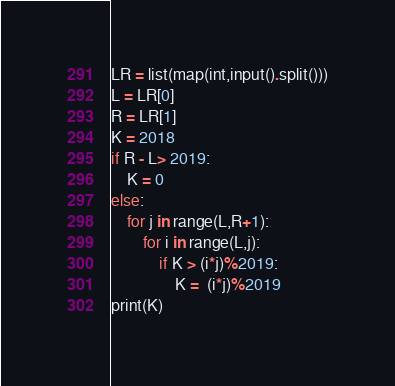Convert code to text. <code><loc_0><loc_0><loc_500><loc_500><_Python_>LR = list(map(int,input().split()))
L = LR[0]
R = LR[1]
K = 2018
if R - L> 2019:
    K = 0
else:
    for j in range(L,R+1):
        for i in range(L,j):
            if K > (i*j)%2019:
                K =  (i*j)%2019
print(K)</code> 